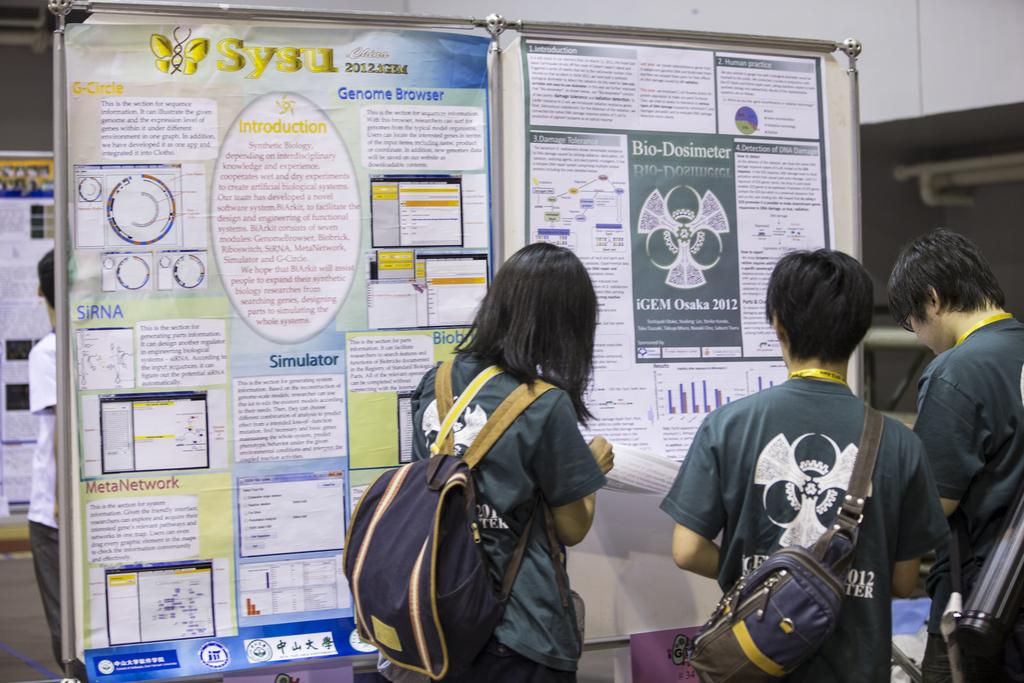What can be observed about the people in the image? There are people standing in the image. Can you describe what the people are wearing? Some people are wearing bags. What else is present in the image besides the people? There are banners in the image. What can be seen in the background of the image? There is a wall in the background of the image. How many children are sitting on the chin of the person in the image? There are no children present in the image, nor is there any mention of a chin. 